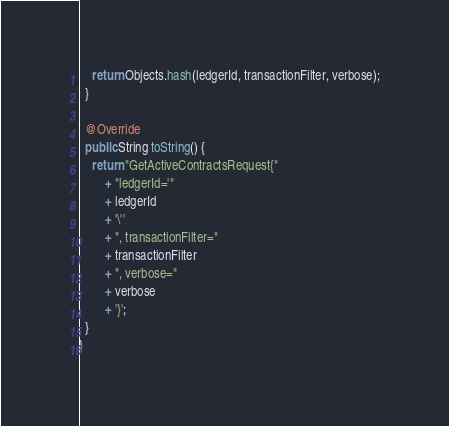<code> <loc_0><loc_0><loc_500><loc_500><_Java_>
    return Objects.hash(ledgerId, transactionFilter, verbose);
  }

  @Override
  public String toString() {
    return "GetActiveContractsRequest{"
        + "ledgerId='"
        + ledgerId
        + '\''
        + ", transactionFilter="
        + transactionFilter
        + ", verbose="
        + verbose
        + '}';
  }
}
</code> 